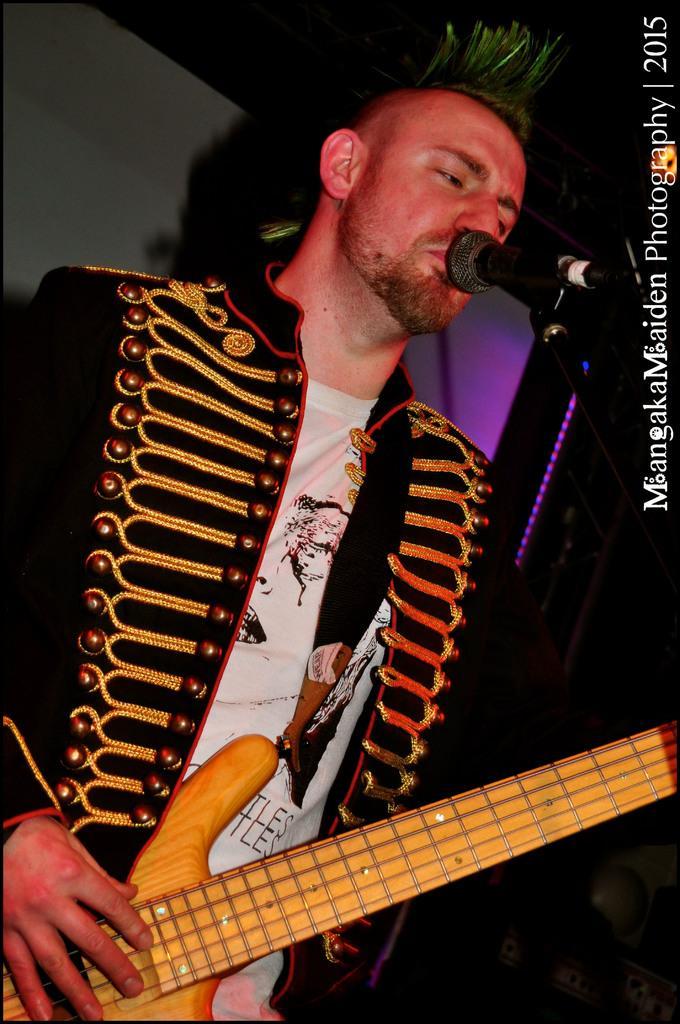Please provide a concise description of this image. There is a man singing in microphone and playing guitar. He is wearing black jacket with embroidery work on it. 